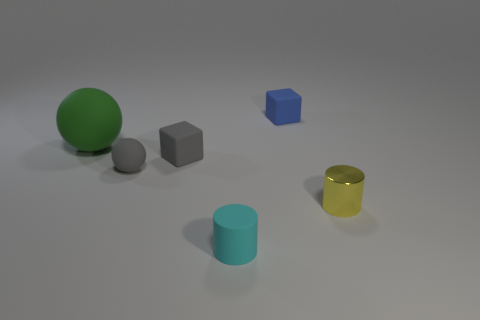Add 1 blue rubber cubes. How many objects exist? 7 Subtract all cubes. How many objects are left? 4 Add 2 small metallic blocks. How many small metallic blocks exist? 2 Subtract 0 brown cylinders. How many objects are left? 6 Subtract all big green matte objects. Subtract all gray matte blocks. How many objects are left? 4 Add 5 tiny cyan things. How many tiny cyan things are left? 6 